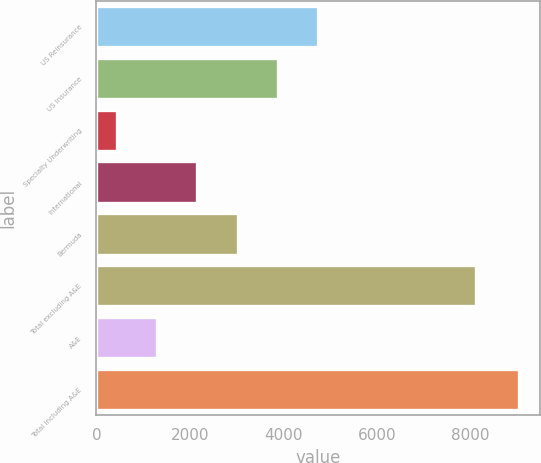Convert chart. <chart><loc_0><loc_0><loc_500><loc_500><bar_chart><fcel>US Reinsurance<fcel>US Insurance<fcel>Specialty Underwriting<fcel>International<fcel>Bermuda<fcel>Total excluding A&E<fcel>A&E<fcel>Total including A&E<nl><fcel>4737.55<fcel>3876.94<fcel>434.5<fcel>2155.72<fcel>3016.33<fcel>8117.8<fcel>1295.11<fcel>9040.6<nl></chart> 